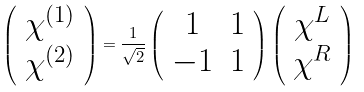<formula> <loc_0><loc_0><loc_500><loc_500>\left ( \begin{array} { c } \chi ^ { ( 1 ) } \\ \chi ^ { ( 2 ) } \end{array} \right ) = \frac { 1 } { \sqrt { 2 } } \left ( \begin{array} { c c } 1 & 1 \\ - 1 & 1 \end{array} \right ) \left ( \begin{array} { c } \chi ^ { L } \\ \chi ^ { R } \end{array} \right )</formula> 